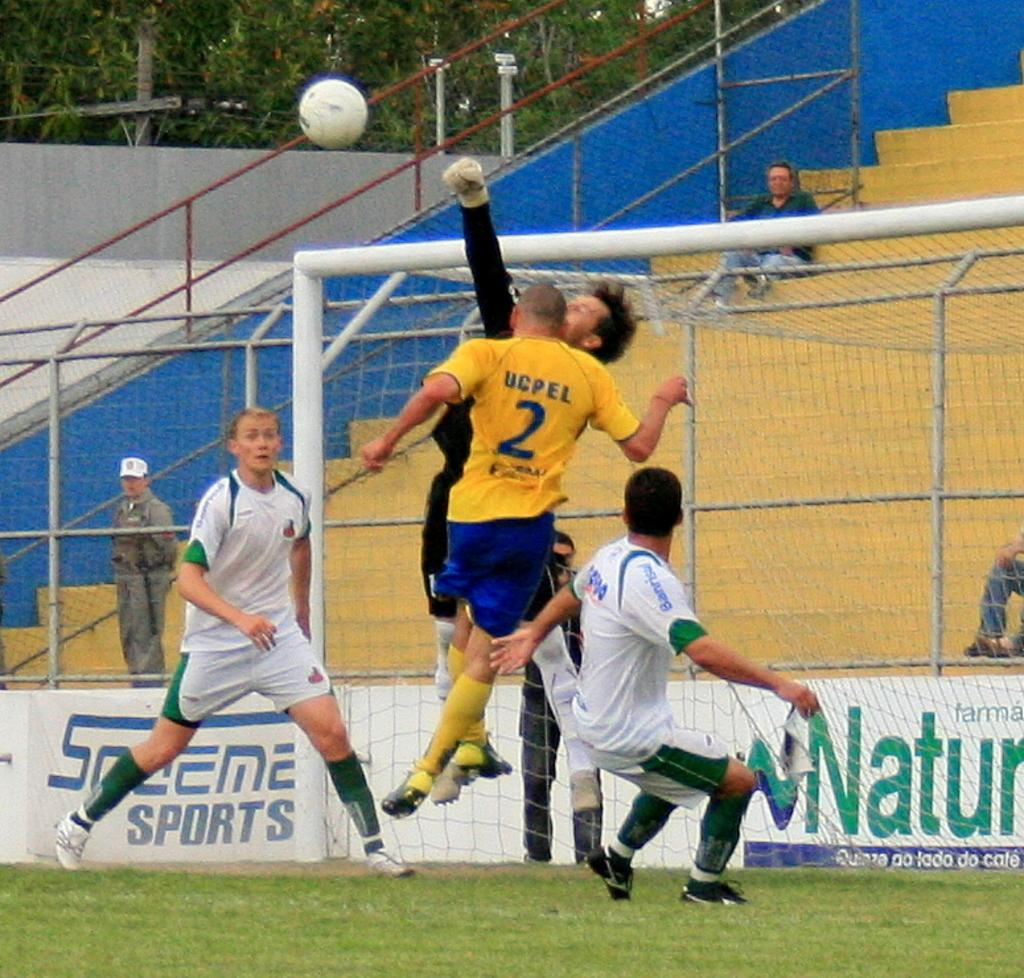What is the person in the image doing? The person is jumping in the image. What color is the person's t-shirt? The person is wearing a yellow t-shirt. What is the man in the image doing? The man is running in the image. What is the man wearing? The man is wearing a white dress. What object is in the air in the image? There is a ball in the air in the image. What color is the ball? The ball is white. How does the person compare their self to the fire in the image? There is no fire present in the image, so it is not possible to make a comparison. 